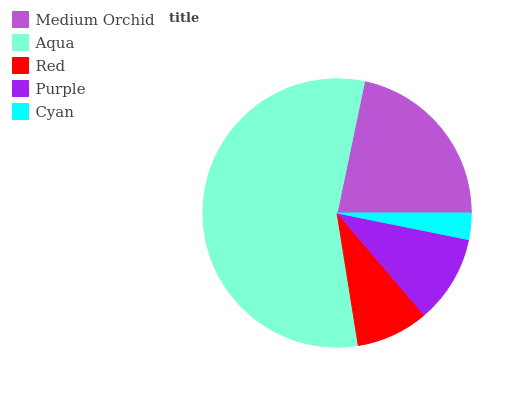Is Cyan the minimum?
Answer yes or no. Yes. Is Aqua the maximum?
Answer yes or no. Yes. Is Red the minimum?
Answer yes or no. No. Is Red the maximum?
Answer yes or no. No. Is Aqua greater than Red?
Answer yes or no. Yes. Is Red less than Aqua?
Answer yes or no. Yes. Is Red greater than Aqua?
Answer yes or no. No. Is Aqua less than Red?
Answer yes or no. No. Is Purple the high median?
Answer yes or no. Yes. Is Purple the low median?
Answer yes or no. Yes. Is Cyan the high median?
Answer yes or no. No. Is Medium Orchid the low median?
Answer yes or no. No. 